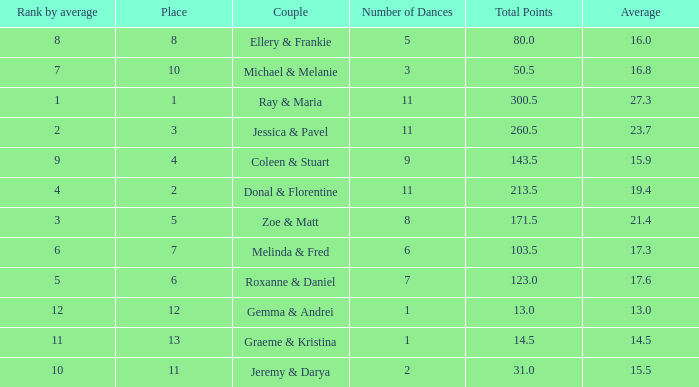What is the couples name where the average is 15.9? Coleen & Stuart. 